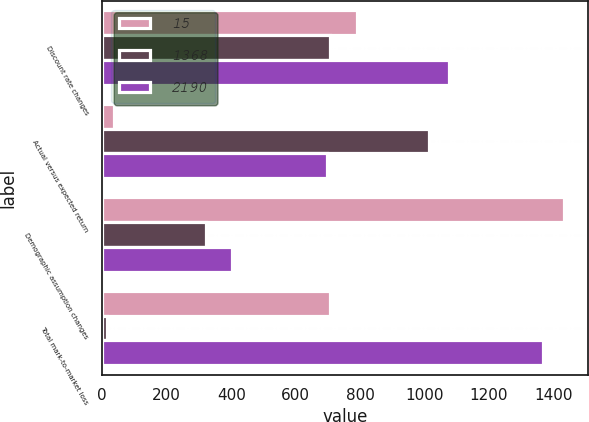Convert chart to OTSL. <chart><loc_0><loc_0><loc_500><loc_500><stacked_bar_chart><ecel><fcel>Discount rate changes<fcel>Actual versus expected return<fcel>Demographic assumption changes<fcel>Total mark-to-market loss<nl><fcel>15<fcel>791<fcel>35<fcel>1434<fcel>705<nl><fcel>1368<fcel>705<fcel>1013<fcel>323<fcel>15<nl><fcel>2190<fcel>1076<fcel>696<fcel>404<fcel>1368<nl></chart> 